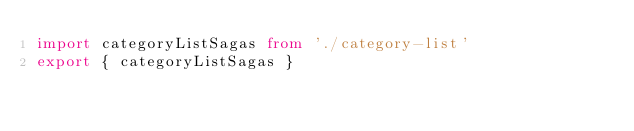<code> <loc_0><loc_0><loc_500><loc_500><_TypeScript_>import categoryListSagas from './category-list'
export { categoryListSagas }
</code> 